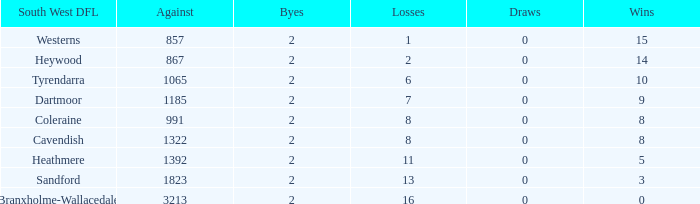In the south west dfl of tyrendarra, how many draws are there with fewer than 10 wins? None. 